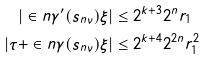Convert formula to latex. <formula><loc_0><loc_0><loc_500><loc_500>| \in n { \gamma ^ { \prime } ( s _ { n \nu } ) } { \xi } | & \leq 2 ^ { k + 3 } 2 ^ { n } r _ { 1 } \\ | \tau + \in n { \gamma ( s _ { n \nu } ) } { \xi } | & \leq 2 ^ { k + 4 } 2 ^ { 2 n } r _ { 1 } ^ { 2 }</formula> 